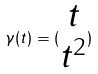Convert formula to latex. <formula><loc_0><loc_0><loc_500><loc_500>\gamma ( t ) = ( \begin{matrix} t \\ t ^ { 2 } \end{matrix} )</formula> 